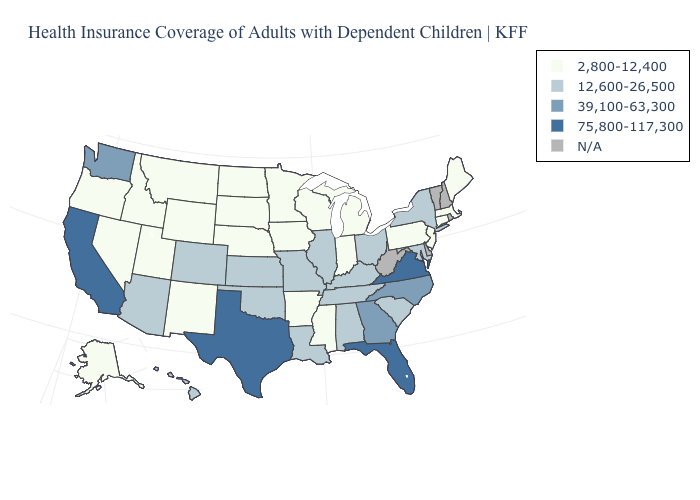Does Massachusetts have the lowest value in the USA?
Short answer required. Yes. What is the lowest value in the USA?
Quick response, please. 2,800-12,400. Name the states that have a value in the range 39,100-63,300?
Concise answer only. Georgia, North Carolina, Washington. Name the states that have a value in the range 75,800-117,300?
Short answer required. California, Florida, Texas, Virginia. Among the states that border Michigan , does Ohio have the lowest value?
Short answer required. No. What is the highest value in the USA?
Give a very brief answer. 75,800-117,300. What is the value of California?
Short answer required. 75,800-117,300. Name the states that have a value in the range 75,800-117,300?
Quick response, please. California, Florida, Texas, Virginia. What is the highest value in states that border Mississippi?
Write a very short answer. 12,600-26,500. What is the lowest value in the South?
Answer briefly. 2,800-12,400. Does the map have missing data?
Keep it brief. Yes. Does the map have missing data?
Write a very short answer. Yes. 